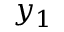Convert formula to latex. <formula><loc_0><loc_0><loc_500><loc_500>y _ { 1 }</formula> 